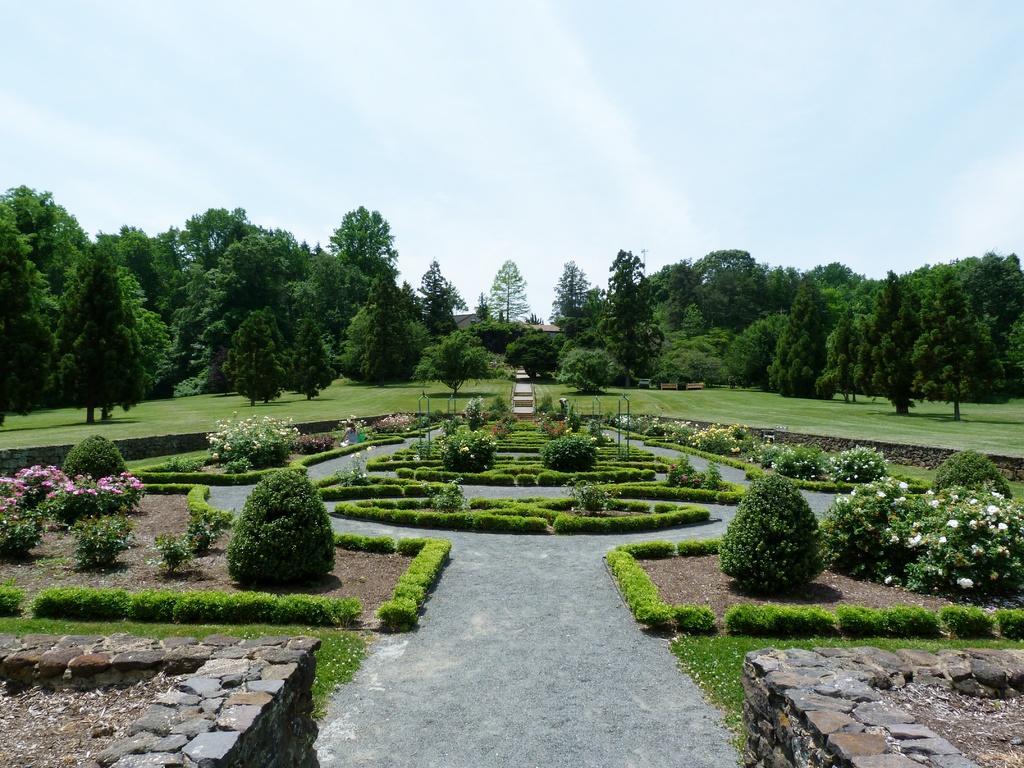Could you give a brief overview of what you see in this image? In this picture, we can see garden with stone walls, plants, trees, grass, poles, and we can see the sky. 